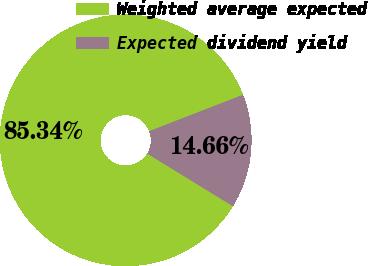Convert chart to OTSL. <chart><loc_0><loc_0><loc_500><loc_500><pie_chart><fcel>Weighted average expected<fcel>Expected dividend yield<nl><fcel>85.34%<fcel>14.66%<nl></chart> 